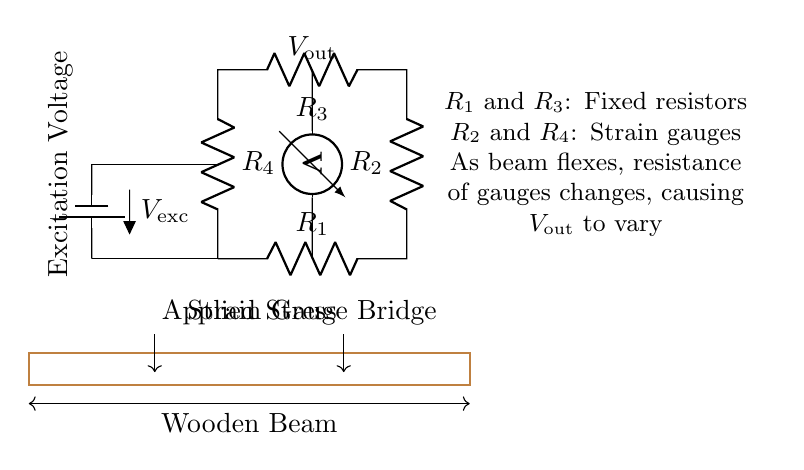What are the fixed resistors in the circuit? The fixed resistors in the circuit are labeled R1 and R3. They provide stable resistance values that help balance the bridge.
Answer: R1, R3 What do R2 and R4 represent? R2 and R4 are labeled as strain gauges. These devices change their resistance when a strain is applied, affecting the output voltage.
Answer: Strain gauges What is the output voltage labeled as? The output voltage in the circuit is labeled as Vout, which indicates the voltage difference due to variations in resistance caused by applied stress.
Answer: Vout How many resistors are in the bridge circuit? There are four resistors in the bridge circuit, consisting of two fixed resistors and two strain gauges.
Answer: Four What is the significance of Vexc in the circuit? Vexc, labeled as the excitation voltage, powers the circuit and allows the strain gauges to function properly by providing a reference voltage.
Answer: Excitation Voltage What happens to Vout when stress is applied? When stress is applied to the wooden beam, the resistance of R2 and R4 changes, which causes Vout to vary as the strain gauges respond to the stress.
Answer: Vout varies What type of circuit is shown in the diagram? The circuit depicted is a strain gauge bridge circuit, specialized for detecting structural stress in materials, particularly wooden beams in this case.
Answer: Strain gauge bridge circuit 